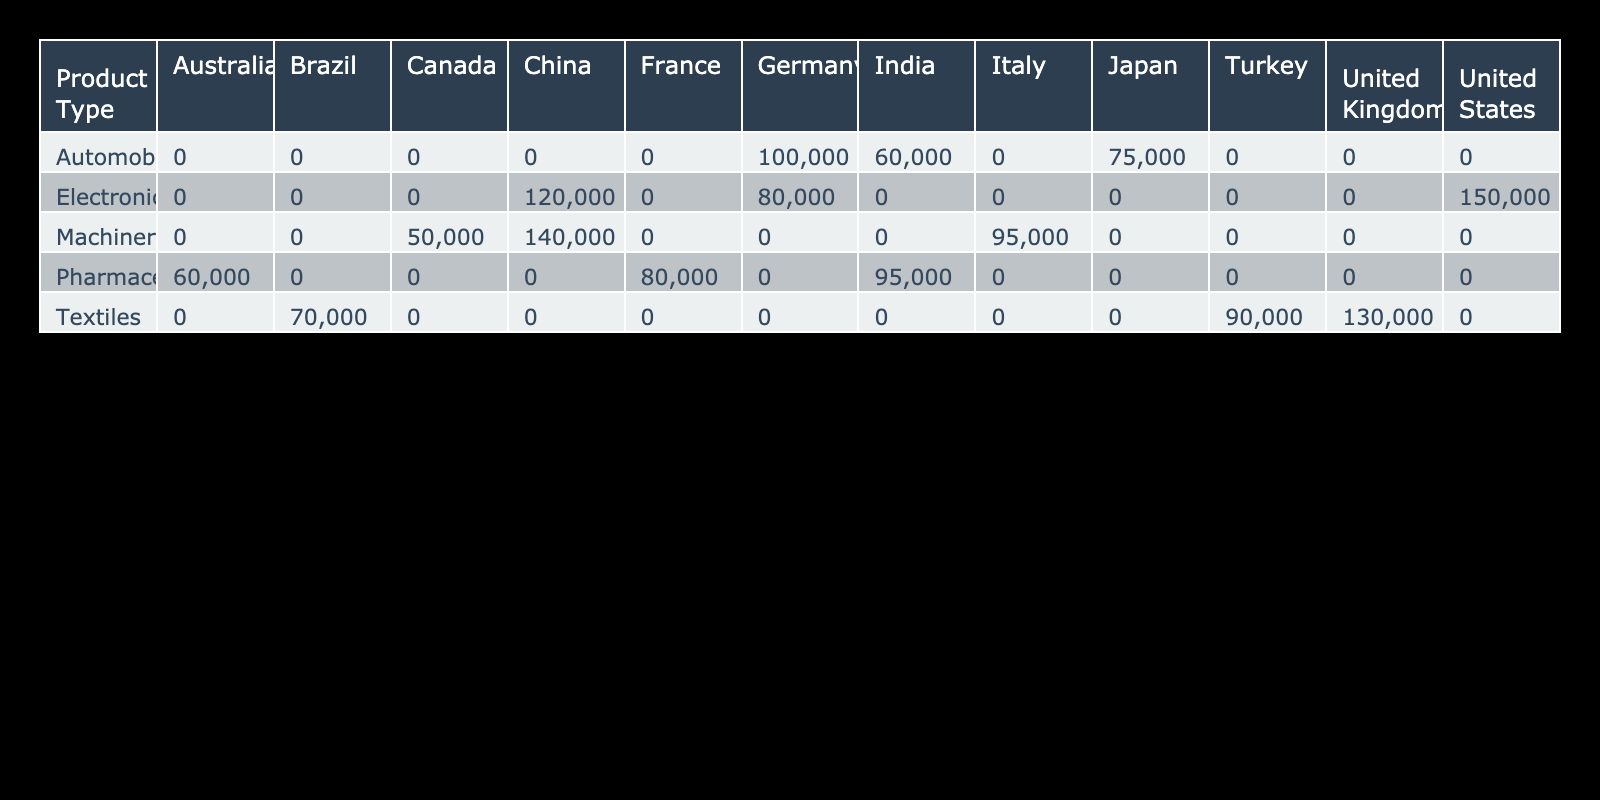What is the export volume of Electronics to the United States? According to the table, the export volume of Electronics specifically to the United States is given as 150,000 units.
Answer: 150,000 Which product type has the highest export volume to Germany? By reviewing the table, we see that both Electronics and Automobiles are exported to Germany, with volumes of 80,000 and 100,000 units respectively. Automobiles has the highest volume of 100,000 units.
Answer: Automobiles What is the total export volume of Machinery to all destination countries? To find the total export volume of Machinery, we look for the relevant values in the table, which are 140,000 (China), 95,000 (Italy), and 50,000 (Canada). Adding them together gives us 140,000 + 95,000 + 50,000 = 285,000 units.
Answer: 285,000 Is the export volume of Pharmaceuticals to India greater than that to Australia? The table shows that the export volume of Pharmaceuticals to India is 95,000 units, while to Australia it is 60,000 units. Since 95,000 is greater than 60,000, the statement is true.
Answer: Yes What is the average export volume of Textiles across its destination countries? The export volumes of Textiles are listed as 130,000 (United Kingdom), 70,000 (Brazil), and 90,000 (Turkey). To find the average, we first sum these volumes: 130,000 + 70,000 + 90,000 = 290,000, then divide by the number of destinations (3), which results in an average of 290,000 / 3 = 96,667.
Answer: 96,667 Which destination country receives the highest volume of exports across all product types? Evaluating the table across all destination countries and summing their respective exports, we find: United States (150,000), China (120,000), Germany (80,000 + 100,000), Japan (75,000), India (60,000 + 95,000), Italy (95,000), Canada (50,000), United Kingdom (130,000), Brazil (70,000), Turkey (90,000), and France (80,000). The maximum total is for the United States at 150,000.
Answer: United States How many countries are exporting Automobiles? Automobiles are exported to three countries as per the data in the table, which are Germany, Japan, and India.
Answer: 3 What is the total export volume to China for all product types? To determine the total export volume to China, we collect the relevant volumes for each product: Electronics (120,000) and Machinery (140,000). Adding these volumes together gives us 120,000 + 140,000 = 260,000.
Answer: 260,000 Does Brazil receive more exports of Textiles than any other country? In the table, Brazil's exports of Textiles amount to 70,000 units. Comparatively, the United Kingdom receives 130,000 units in textiles, which is higher. Therefore, the statement is false.
Answer: No 